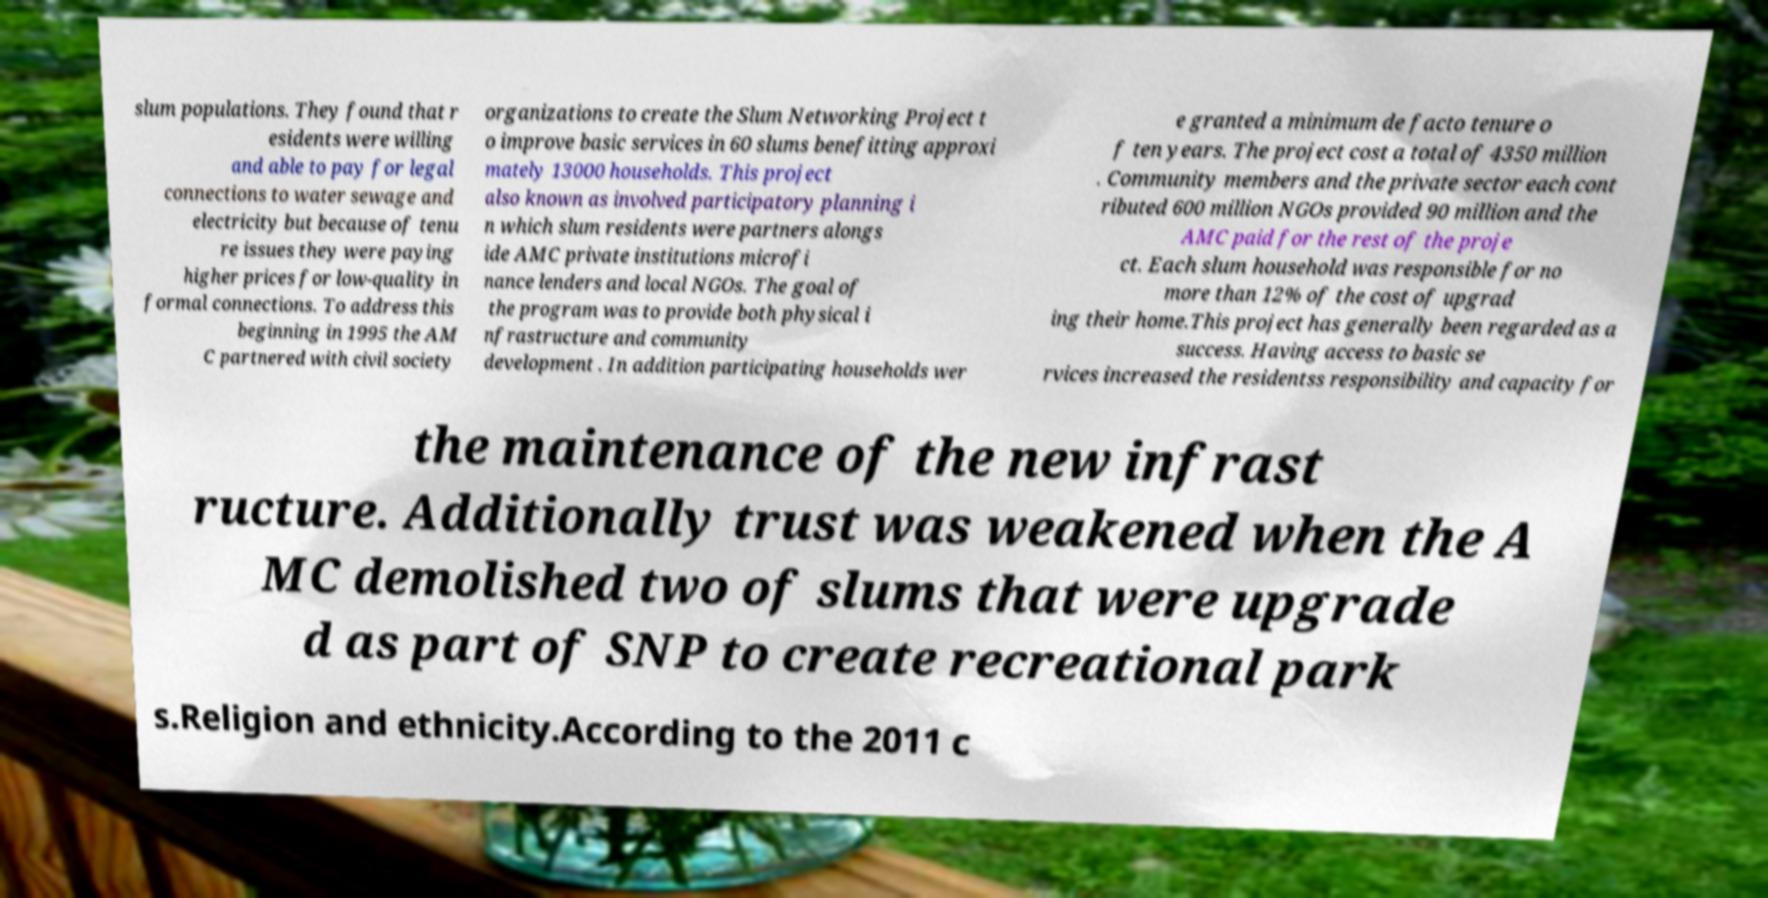There's text embedded in this image that I need extracted. Can you transcribe it verbatim? slum populations. They found that r esidents were willing and able to pay for legal connections to water sewage and electricity but because of tenu re issues they were paying higher prices for low-quality in formal connections. To address this beginning in 1995 the AM C partnered with civil society organizations to create the Slum Networking Project t o improve basic services in 60 slums benefitting approxi mately 13000 households. This project also known as involved participatory planning i n which slum residents were partners alongs ide AMC private institutions microfi nance lenders and local NGOs. The goal of the program was to provide both physical i nfrastructure and community development . In addition participating households wer e granted a minimum de facto tenure o f ten years. The project cost a total of 4350 million . Community members and the private sector each cont ributed 600 million NGOs provided 90 million and the AMC paid for the rest of the proje ct. Each slum household was responsible for no more than 12% of the cost of upgrad ing their home.This project has generally been regarded as a success. Having access to basic se rvices increased the residentss responsibility and capacity for the maintenance of the new infrast ructure. Additionally trust was weakened when the A MC demolished two of slums that were upgrade d as part of SNP to create recreational park s.Religion and ethnicity.According to the 2011 c 